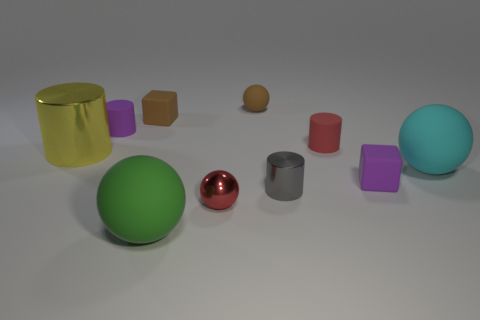Subtract 1 balls. How many balls are left? 3 Subtract all cylinders. How many objects are left? 6 Subtract all big yellow shiny spheres. Subtract all brown rubber cubes. How many objects are left? 9 Add 8 matte blocks. How many matte blocks are left? 10 Add 7 large cyan rubber objects. How many large cyan rubber objects exist? 8 Subtract 1 purple blocks. How many objects are left? 9 